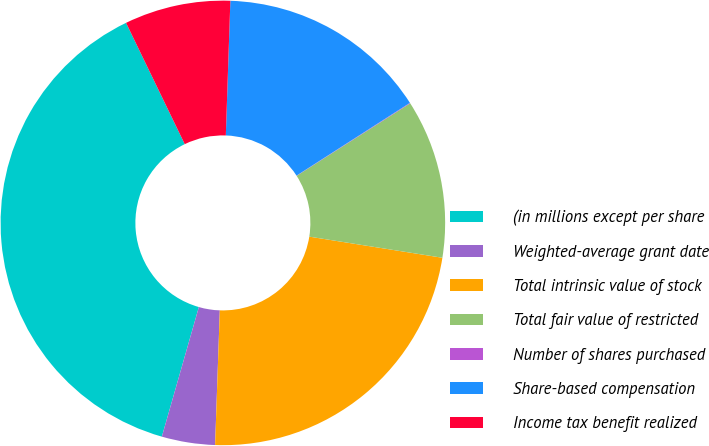<chart> <loc_0><loc_0><loc_500><loc_500><pie_chart><fcel>(in millions except per share<fcel>Weighted-average grant date<fcel>Total intrinsic value of stock<fcel>Total fair value of restricted<fcel>Number of shares purchased<fcel>Share-based compensation<fcel>Income tax benefit realized<nl><fcel>38.4%<fcel>3.87%<fcel>23.05%<fcel>11.55%<fcel>0.04%<fcel>15.38%<fcel>7.71%<nl></chart> 